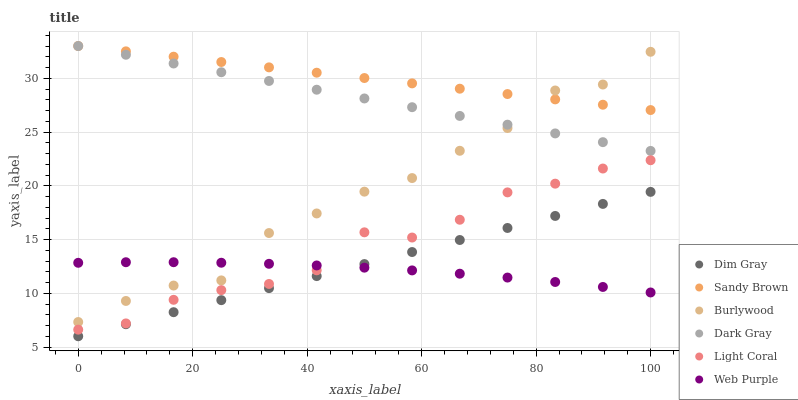Does Web Purple have the minimum area under the curve?
Answer yes or no. Yes. Does Sandy Brown have the maximum area under the curve?
Answer yes or no. Yes. Does Dim Gray have the minimum area under the curve?
Answer yes or no. No. Does Dim Gray have the maximum area under the curve?
Answer yes or no. No. Is Dim Gray the smoothest?
Answer yes or no. Yes. Is Burlywood the roughest?
Answer yes or no. Yes. Is Burlywood the smoothest?
Answer yes or no. No. Is Dim Gray the roughest?
Answer yes or no. No. Does Dim Gray have the lowest value?
Answer yes or no. Yes. Does Burlywood have the lowest value?
Answer yes or no. No. Does Sandy Brown have the highest value?
Answer yes or no. Yes. Does Dim Gray have the highest value?
Answer yes or no. No. Is Dim Gray less than Dark Gray?
Answer yes or no. Yes. Is Sandy Brown greater than Light Coral?
Answer yes or no. Yes. Does Web Purple intersect Burlywood?
Answer yes or no. Yes. Is Web Purple less than Burlywood?
Answer yes or no. No. Is Web Purple greater than Burlywood?
Answer yes or no. No. Does Dim Gray intersect Dark Gray?
Answer yes or no. No. 